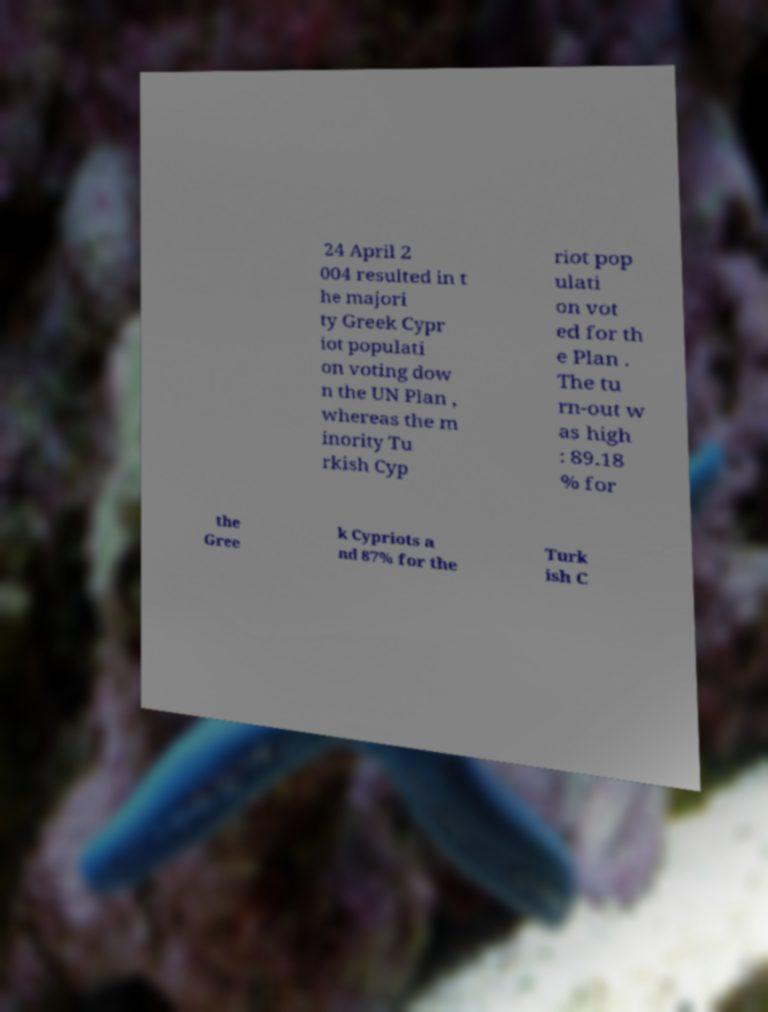Can you accurately transcribe the text from the provided image for me? 24 April 2 004 resulted in t he majori ty Greek Cypr iot populati on voting dow n the UN Plan , whereas the m inority Tu rkish Cyp riot pop ulati on vot ed for th e Plan . The tu rn-out w as high : 89.18 % for the Gree k Cypriots a nd 87% for the Turk ish C 